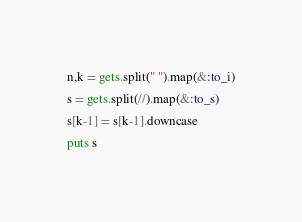<code> <loc_0><loc_0><loc_500><loc_500><_Ruby_>n,k = gets.split(" ").map(&:to_i)
s = gets.split(//).map(&:to_s)
s[k-1] = s[k-1].downcase
puts s</code> 